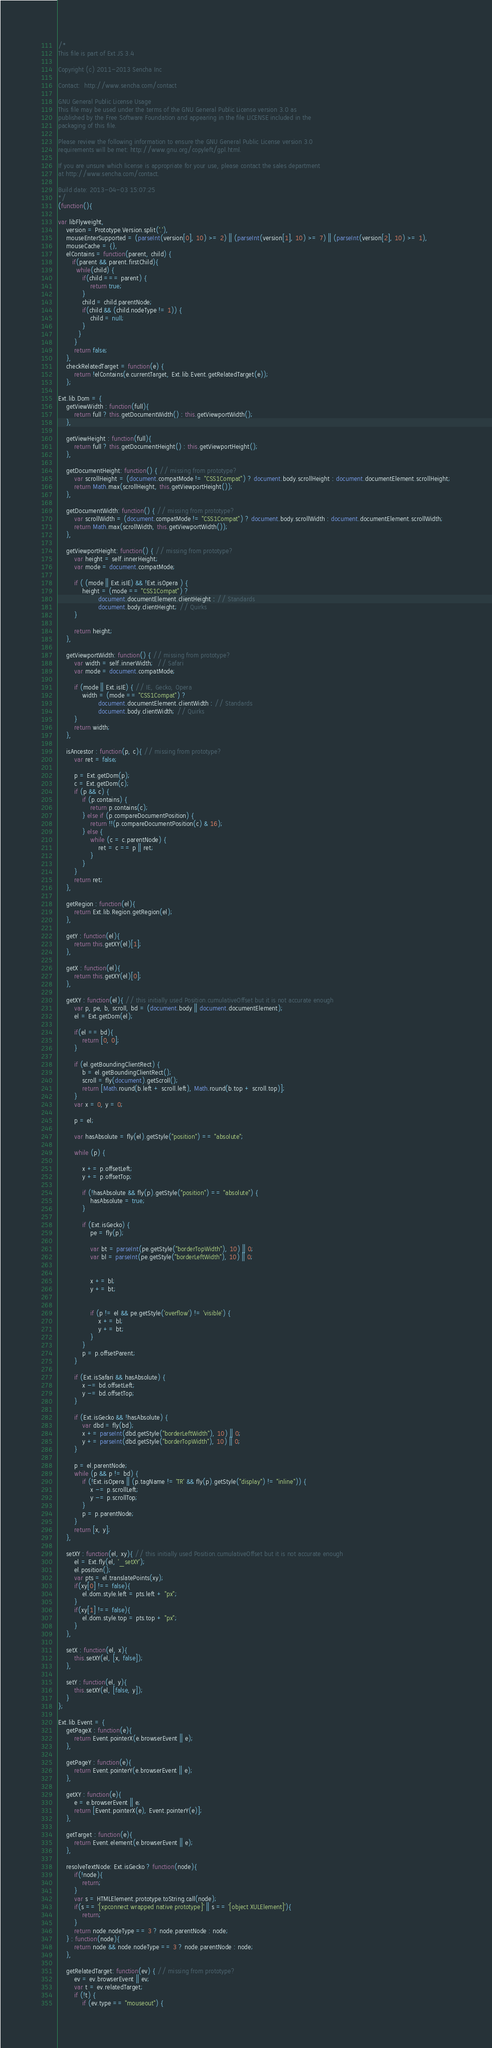Convert code to text. <code><loc_0><loc_0><loc_500><loc_500><_JavaScript_>/*
This file is part of Ext JS 3.4

Copyright (c) 2011-2013 Sencha Inc

Contact:  http://www.sencha.com/contact

GNU General Public License Usage
This file may be used under the terms of the GNU General Public License version 3.0 as
published by the Free Software Foundation and appearing in the file LICENSE included in the
packaging of this file.

Please review the following information to ensure the GNU General Public License version 3.0
requirements will be met: http://www.gnu.org/copyleft/gpl.html.

If you are unsure which license is appropriate for your use, please contact the sales department
at http://www.sencha.com/contact.

Build date: 2013-04-03 15:07:25
*/
(function(){

var libFlyweight,
    version = Prototype.Version.split('.'),
    mouseEnterSupported = (parseInt(version[0], 10) >= 2) || (parseInt(version[1], 10) >= 7) || (parseInt(version[2], 10) >= 1),
    mouseCache = {},
    elContains = function(parent, child) {
       if(parent && parent.firstChild){
         while(child) {
            if(child === parent) {
                return true;
            }
            child = child.parentNode;
            if(child && (child.nodeType != 1)) {
                child = null;
            }
          }
        }
        return false;
    },
    checkRelatedTarget = function(e) {
        return !elContains(e.currentTarget, Ext.lib.Event.getRelatedTarget(e));
    };

Ext.lib.Dom = {
    getViewWidth : function(full){
        return full ? this.getDocumentWidth() : this.getViewportWidth();
    },

    getViewHeight : function(full){
        return full ? this.getDocumentHeight() : this.getViewportHeight();
    },

    getDocumentHeight: function() { // missing from prototype?
        var scrollHeight = (document.compatMode != "CSS1Compat") ? document.body.scrollHeight : document.documentElement.scrollHeight;
        return Math.max(scrollHeight, this.getViewportHeight());
    },

    getDocumentWidth: function() { // missing from prototype?
        var scrollWidth = (document.compatMode != "CSS1Compat") ? document.body.scrollWidth : document.documentElement.scrollWidth;
        return Math.max(scrollWidth, this.getViewportWidth());
    },

    getViewportHeight: function() { // missing from prototype?
        var height = self.innerHeight;
        var mode = document.compatMode;

        if ( (mode || Ext.isIE) && !Ext.isOpera ) {
            height = (mode == "CSS1Compat") ?
                    document.documentElement.clientHeight : // Standards
                    document.body.clientHeight; // Quirks
        }

        return height;
    },

    getViewportWidth: function() { // missing from prototype?
        var width = self.innerWidth;  // Safari
        var mode = document.compatMode;

        if (mode || Ext.isIE) { // IE, Gecko, Opera
            width = (mode == "CSS1Compat") ?
                    document.documentElement.clientWidth : // Standards
                    document.body.clientWidth; // Quirks
        }
        return width;
    },

    isAncestor : function(p, c){ // missing from prototype?
        var ret = false;

        p = Ext.getDom(p);
        c = Ext.getDom(c);
        if (p && c) {
            if (p.contains) {
                return p.contains(c);
            } else if (p.compareDocumentPosition) {
                return !!(p.compareDocumentPosition(c) & 16);
            } else {
                while (c = c.parentNode) {
                    ret = c == p || ret;
                }
            }
        }
        return ret;
    },

    getRegion : function(el){
        return Ext.lib.Region.getRegion(el);
    },

    getY : function(el){
        return this.getXY(el)[1];
    },

    getX : function(el){
        return this.getXY(el)[0];
    },

    getXY : function(el){ // this initially used Position.cumulativeOffset but it is not accurate enough
        var p, pe, b, scroll, bd = (document.body || document.documentElement);
        el = Ext.getDom(el);

        if(el == bd){
            return [0, 0];
        }

        if (el.getBoundingClientRect) {
            b = el.getBoundingClientRect();
            scroll = fly(document).getScroll();
            return [Math.round(b.left + scroll.left), Math.round(b.top + scroll.top)];
        }
        var x = 0, y = 0;

        p = el;

        var hasAbsolute = fly(el).getStyle("position") == "absolute";

        while (p) {

            x += p.offsetLeft;
            y += p.offsetTop;

            if (!hasAbsolute && fly(p).getStyle("position") == "absolute") {
                hasAbsolute = true;
            }

            if (Ext.isGecko) {
                pe = fly(p);

                var bt = parseInt(pe.getStyle("borderTopWidth"), 10) || 0;
                var bl = parseInt(pe.getStyle("borderLeftWidth"), 10) || 0;


                x += bl;
                y += bt;


                if (p != el && pe.getStyle('overflow') != 'visible') {
                    x += bl;
                    y += bt;
                }
            }
            p = p.offsetParent;
        }

        if (Ext.isSafari && hasAbsolute) {
            x -= bd.offsetLeft;
            y -= bd.offsetTop;
        }

        if (Ext.isGecko && !hasAbsolute) {
            var dbd = fly(bd);
            x += parseInt(dbd.getStyle("borderLeftWidth"), 10) || 0;
            y += parseInt(dbd.getStyle("borderTopWidth"), 10) || 0;
        }

        p = el.parentNode;
        while (p && p != bd) {
            if (!Ext.isOpera || (p.tagName != 'TR' && fly(p).getStyle("display") != "inline")) {
                x -= p.scrollLeft;
                y -= p.scrollTop;
            }
            p = p.parentNode;
        }
        return [x, y];
    },

    setXY : function(el, xy){ // this initially used Position.cumulativeOffset but it is not accurate enough
        el = Ext.fly(el, '_setXY');
        el.position();
        var pts = el.translatePoints(xy);
        if(xy[0] !== false){
            el.dom.style.left = pts.left + "px";
        }
        if(xy[1] !== false){
            el.dom.style.top = pts.top + "px";
        }
    },

    setX : function(el, x){
        this.setXY(el, [x, false]);
    },

    setY : function(el, y){
        this.setXY(el, [false, y]);
    }
};

Ext.lib.Event = {
    getPageX : function(e){
        return Event.pointerX(e.browserEvent || e);
    },

    getPageY : function(e){
        return Event.pointerY(e.browserEvent || e);
    },

    getXY : function(e){
        e = e.browserEvent || e;
        return [Event.pointerX(e), Event.pointerY(e)];
    },

    getTarget : function(e){
        return Event.element(e.browserEvent || e);
    },

    resolveTextNode: Ext.isGecko ? function(node){
        if(!node){
            return;
        }
        var s = HTMLElement.prototype.toString.call(node);
        if(s == '[xpconnect wrapped native prototype]' || s == '[object XULElement]'){
            return;
        }
        return node.nodeType == 3 ? node.parentNode : node;
    } : function(node){
        return node && node.nodeType == 3 ? node.parentNode : node;
    },

    getRelatedTarget: function(ev) { // missing from prototype?
        ev = ev.browserEvent || ev;
        var t = ev.relatedTarget;
        if (!t) {
            if (ev.type == "mouseout") {</code> 